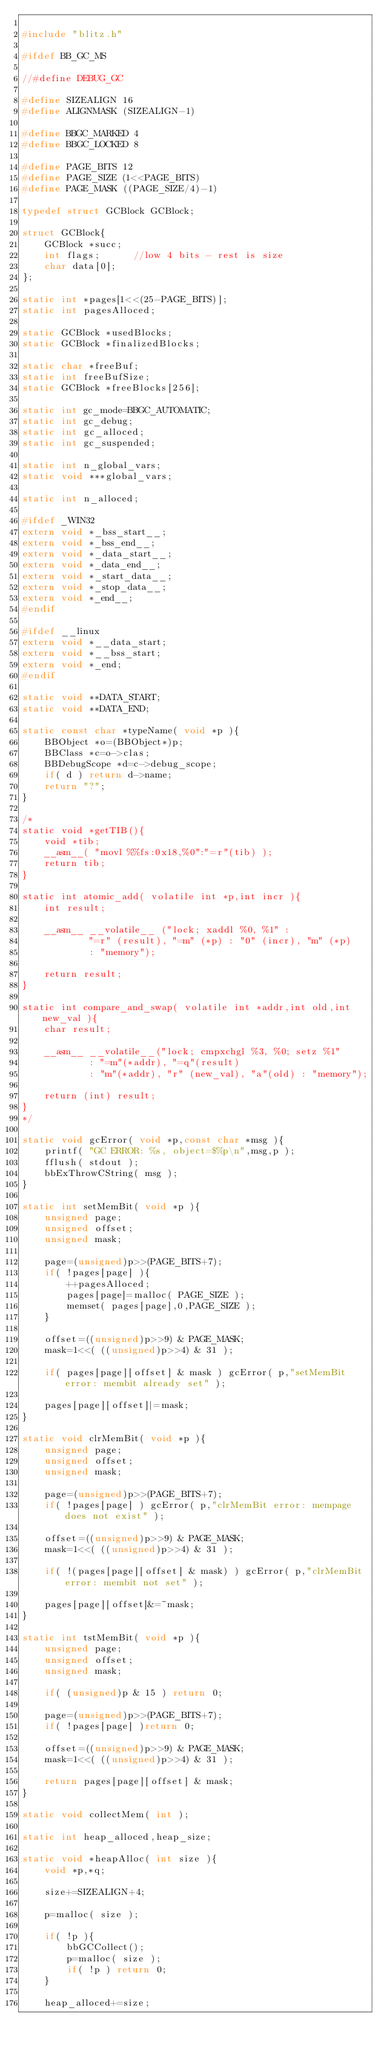<code> <loc_0><loc_0><loc_500><loc_500><_C_>
#include "blitz.h"

#ifdef BB_GC_MS

//#define DEBUG_GC

#define SIZEALIGN 16
#define ALIGNMASK (SIZEALIGN-1)

#define BBGC_MARKED 4
#define BBGC_LOCKED 8

#define PAGE_BITS 12
#define PAGE_SIZE (1<<PAGE_BITS)
#define PAGE_MASK ((PAGE_SIZE/4)-1)

typedef struct GCBlock GCBlock;

struct GCBlock{
	GCBlock *succ;
	int flags;		//low 4 bits - rest is size
	char data[0];
};

static int *pages[1<<(25-PAGE_BITS)];
static int pagesAlloced;

static GCBlock *usedBlocks;
static GCBlock *finalizedBlocks;

static char *freeBuf;
static int freeBufSize;
static GCBlock *freeBlocks[256];

static int gc_mode=BBGC_AUTOMATIC;
static int gc_debug;
static int gc_alloced;
static int gc_suspended;

static int n_global_vars;
static void ***global_vars;

static int n_alloced;

#ifdef _WIN32
extern void *_bss_start__;
extern void *_bss_end__;
extern void *_data_start__;
extern void *_data_end__;
extern void *_start_data__;
extern void *_stop_data__;
extern void *_end__;
#endif

#ifdef __linux
extern void *__data_start;
extern void *__bss_start;
extern void *_end;
#endif

static void **DATA_START;
static void **DATA_END;

static const char *typeName( void *p ){
	BBObject *o=(BBObject*)p;
	BBClass *c=o->clas;
	BBDebugScope *d=c->debug_scope;
	if( d ) return d->name;
	return "?";
}

/*
static void *getTIB(){
	void *tib;
	__asm__( "movl %%fs:0x18,%0":"=r"(tib) );
    return tib;
}

static int atomic_add( volatile int *p,int incr ){
	int result;

	__asm__ __volatile__ ("lock; xaddl %0, %1" :
			"=r" (result), "=m" (*p) : "0" (incr), "m" (*p)
			: "memory");

	return result;
}

static int compare_and_swap( volatile int *addr,int old,int new_val ){
	char result;

	__asm__ __volatile__("lock; cmpxchgl %3, %0; setz %1"
			: "=m"(*addr), "=q"(result)
			: "m"(*addr), "r" (new_val), "a"(old) : "memory");

	return (int) result;
}
*/

static void gcError( void *p,const char *msg ){
	printf( "GC ERROR: %s, object=$%p\n",msg,p );
	fflush( stdout );	
	bbExThrowCString( msg );
}

static int setMemBit( void *p ){
	unsigned page;
	unsigned offset;
	unsigned mask;
	
	page=(unsigned)p>>(PAGE_BITS+7);
	if( !pages[page] ){
		++pagesAlloced;
		pages[page]=malloc( PAGE_SIZE );
		memset( pages[page],0,PAGE_SIZE );
	}

	offset=((unsigned)p>>9) & PAGE_MASK;
	mask=1<<( ((unsigned)p>>4) & 31 );
	
	if( pages[page][offset] & mask ) gcError( p,"setMemBit error: membit already set" );

	pages[page][offset]|=mask;
}

static void clrMemBit( void *p ){
	unsigned page;
	unsigned offset;
	unsigned mask;

	page=(unsigned)p>>(PAGE_BITS+7);
	if( !pages[page] ) gcError( p,"clrMemBit error: mempage does not exist" );

	offset=((unsigned)p>>9) & PAGE_MASK;
	mask=1<<( ((unsigned)p>>4) & 31 );

	if( !(pages[page][offset] & mask) ) gcError( p,"clrMemBit error: membit not set" );

	pages[page][offset]&=~mask;
}

static int tstMemBit( void *p ){
	unsigned page;
	unsigned offset;
	unsigned mask;

	if( (unsigned)p & 15 ) return 0;

	page=(unsigned)p>>(PAGE_BITS+7);
	if( !pages[page] )return 0;

	offset=((unsigned)p>>9) & PAGE_MASK;
	mask=1<<( ((unsigned)p>>4) & 31 );

	return pages[page][offset] & mask;
}

static void collectMem( int );

static int heap_alloced,heap_size;

static void *heapAlloc( int size ){
	void *p,*q;
	
	size+=SIZEALIGN+4;
	
	p=malloc( size );
	
	if( !p ){
		bbGCCollect();
		p=malloc( size );
		if( !p ) return 0;
	}

	heap_alloced+=size;
</code> 